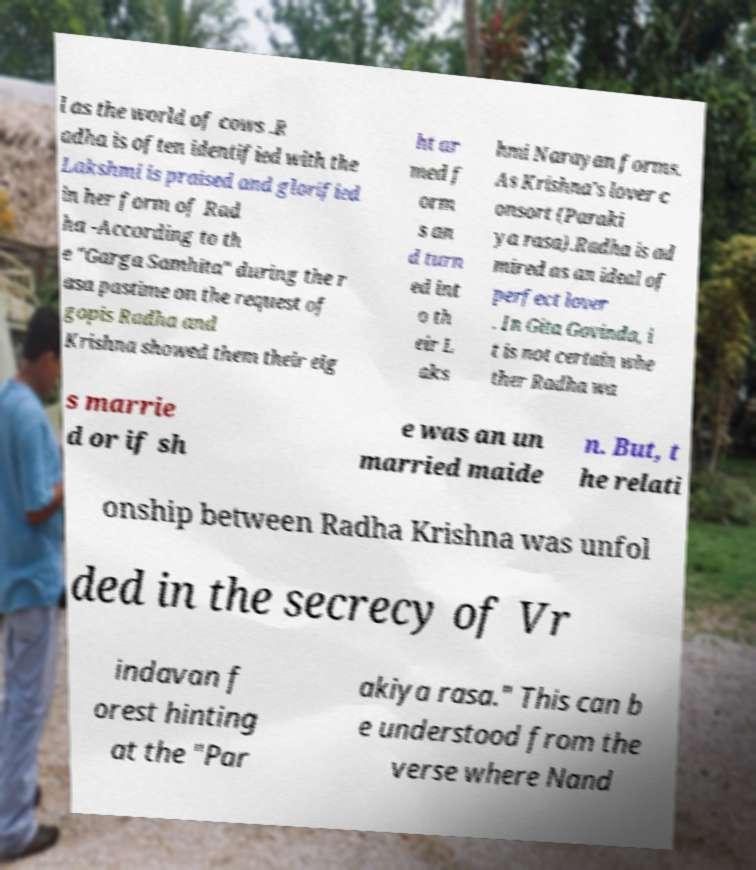For documentation purposes, I need the text within this image transcribed. Could you provide that? l as the world of cows .R adha is often identified with the Lakshmi is praised and glorified in her form of Rad ha -According to th e "Garga Samhita" during the r asa pastime on the request of gopis Radha and Krishna showed them their eig ht ar med f orm s an d turn ed int o th eir L aks hmi Narayan forms. As Krishna's lover c onsort (Paraki ya rasa).Radha is ad mired as an ideal of perfect lover . In Gita Govinda, i t is not certain whe ther Radha wa s marrie d or if sh e was an un married maide n. But, t he relati onship between Radha Krishna was unfol ded in the secrecy of Vr indavan f orest hinting at the "Par akiya rasa." This can b e understood from the verse where Nand 